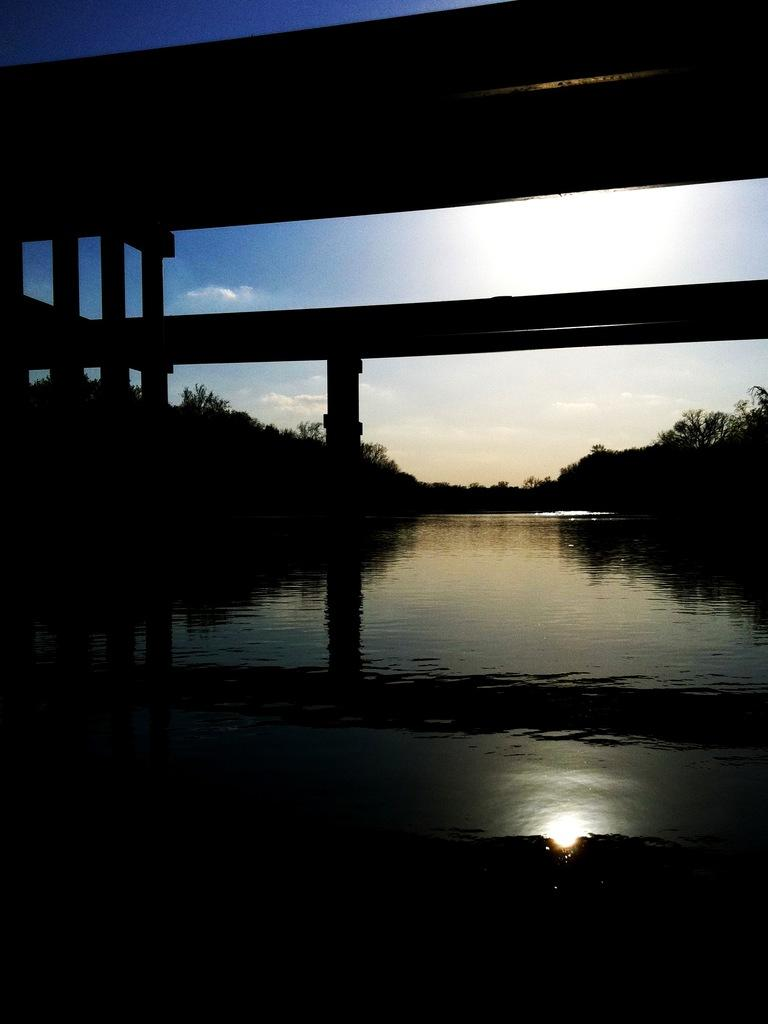Where was the image taken? The image was clicked outside. What is the main subject in the middle of the image? There is water and trees in the middle of the image. What is visible at the top of the image? The sky is visible at the top of the image. What type of prison can be seen in the image? There is no prison present in the image. How does the control system work in the image? There is no control system present in the image. 